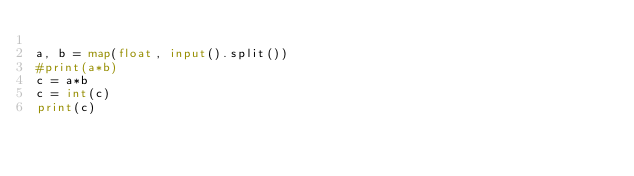Convert code to text. <code><loc_0><loc_0><loc_500><loc_500><_Python_>
a, b = map(float, input().split())
#print(a*b)
c = a*b
c = int(c)
print(c)
</code> 